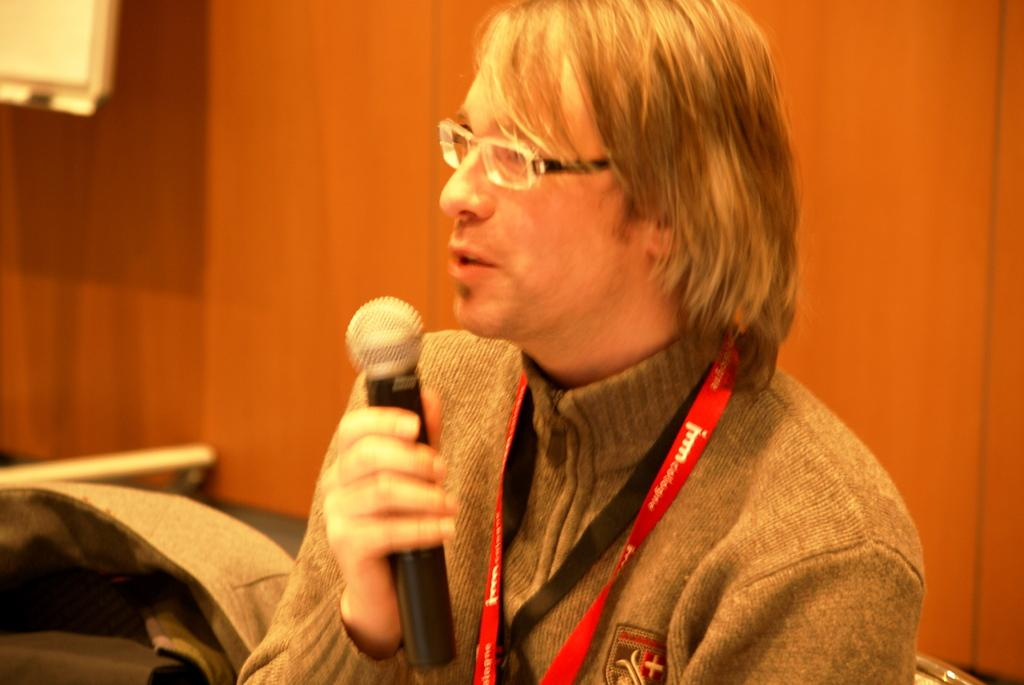What is the person in the image doing? The person is speaking in the image. What is the person holding while speaking? The person is holding a microphone. Can you describe the person's appearance? The person is wearing spectacles and a red ID card. What is the color of the background in the image? The background in the image is brown. What type of texture can be seen on the person's shoes in the image? There is no information about the person's shoes in the provided facts, so we cannot determine the texture. 